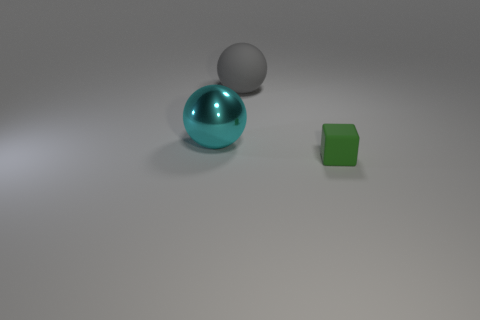Add 2 cyan metal objects. How many objects exist? 5 Subtract 1 spheres. How many spheres are left? 1 Subtract all cyan balls. How many balls are left? 1 Subtract all blocks. How many objects are left? 2 Subtract all gray spheres. Subtract all red cubes. How many spheres are left? 1 Subtract all red cylinders. How many brown blocks are left? 0 Subtract all blue rubber cylinders. Subtract all large things. How many objects are left? 1 Add 3 small green rubber cubes. How many small green rubber cubes are left? 4 Add 2 cubes. How many cubes exist? 3 Subtract 0 red balls. How many objects are left? 3 